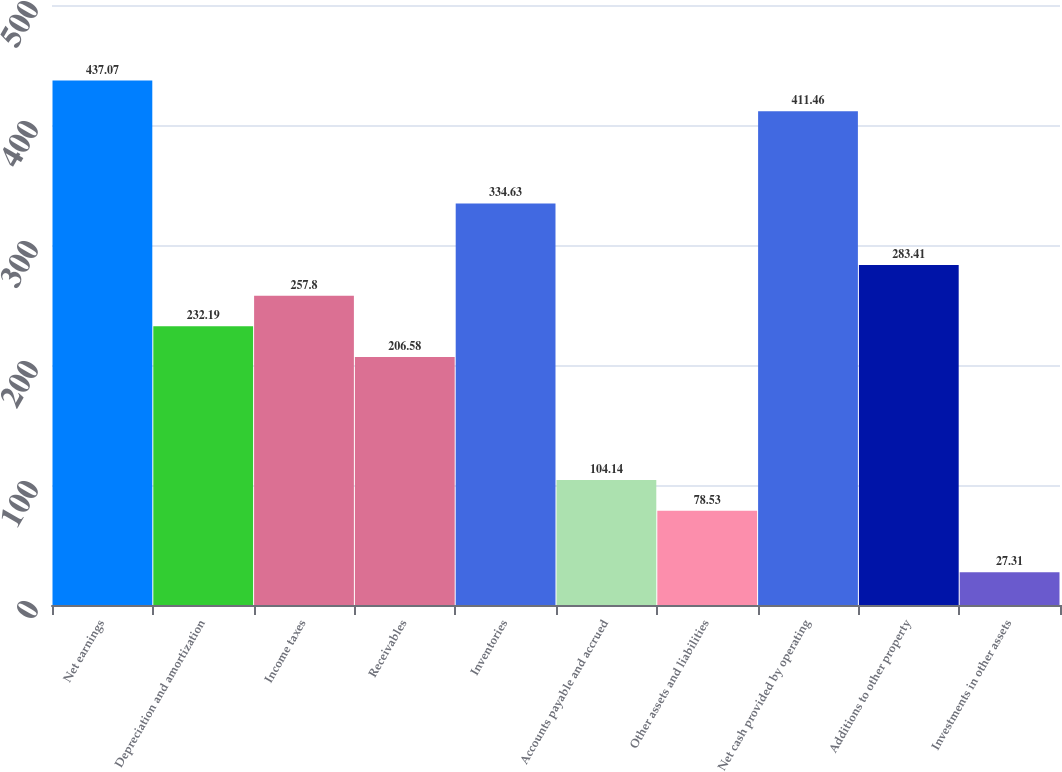Convert chart to OTSL. <chart><loc_0><loc_0><loc_500><loc_500><bar_chart><fcel>Net earnings<fcel>Depreciation and amortization<fcel>Income taxes<fcel>Receivables<fcel>Inventories<fcel>Accounts payable and accrued<fcel>Other assets and liabilities<fcel>Net cash provided by operating<fcel>Additions to other property<fcel>Investments in other assets<nl><fcel>437.07<fcel>232.19<fcel>257.8<fcel>206.58<fcel>334.63<fcel>104.14<fcel>78.53<fcel>411.46<fcel>283.41<fcel>27.31<nl></chart> 